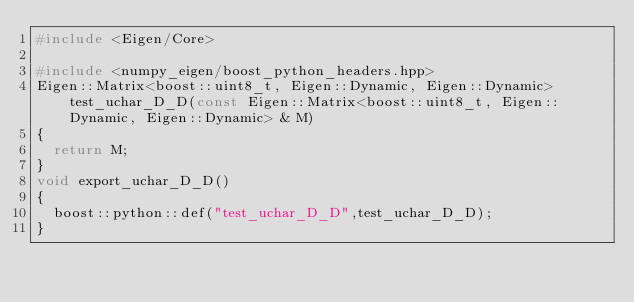<code> <loc_0><loc_0><loc_500><loc_500><_C++_>#include <Eigen/Core>

#include <numpy_eigen/boost_python_headers.hpp>
Eigen::Matrix<boost::uint8_t, Eigen::Dynamic, Eigen::Dynamic> test_uchar_D_D(const Eigen::Matrix<boost::uint8_t, Eigen::Dynamic, Eigen::Dynamic> & M)
{
	return M;
}
void export_uchar_D_D()
{
	boost::python::def("test_uchar_D_D",test_uchar_D_D);
}

</code> 